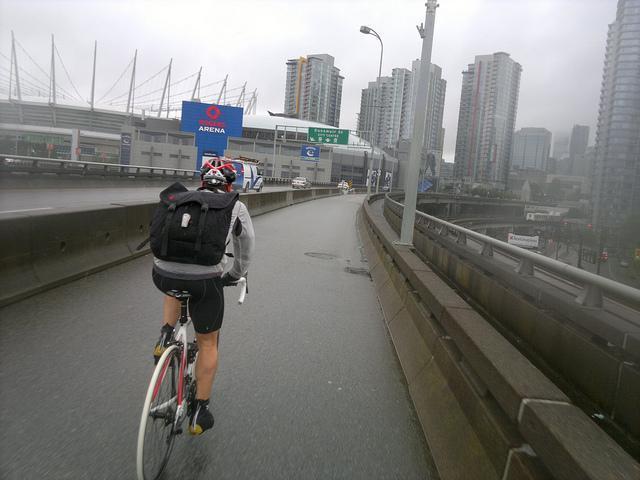How many signs are in the picture?
Give a very brief answer. 3. How many hands does the gold-rimmed clock have?
Give a very brief answer. 0. 